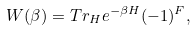<formula> <loc_0><loc_0><loc_500><loc_500>W ( \beta ) = T r _ { H } e ^ { - \beta H } ( - 1 ) ^ { F } ,</formula> 